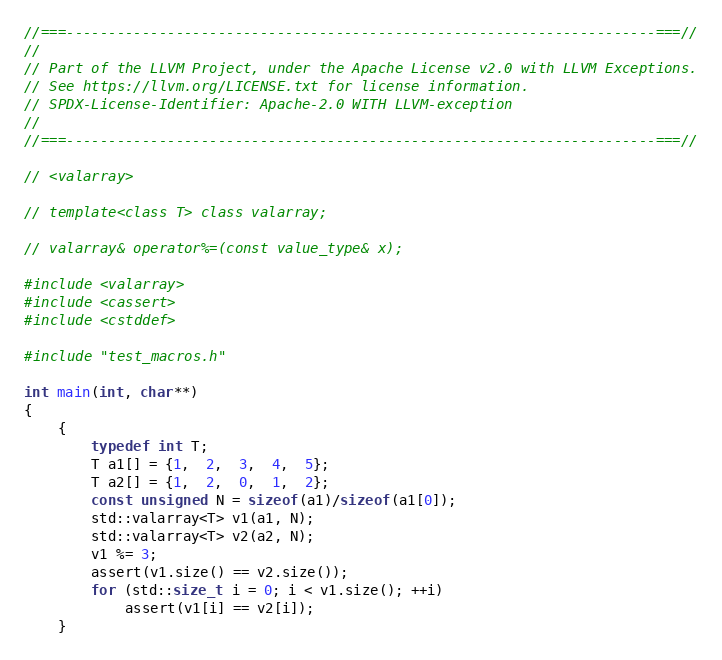<code> <loc_0><loc_0><loc_500><loc_500><_C++_>//===----------------------------------------------------------------------===//
//
// Part of the LLVM Project, under the Apache License v2.0 with LLVM Exceptions.
// See https://llvm.org/LICENSE.txt for license information.
// SPDX-License-Identifier: Apache-2.0 WITH LLVM-exception
//
//===----------------------------------------------------------------------===//

// <valarray>

// template<class T> class valarray;

// valarray& operator%=(const value_type& x);

#include <valarray>
#include <cassert>
#include <cstddef>

#include "test_macros.h"

int main(int, char**)
{
    {
        typedef int T;
        T a1[] = {1,  2,  3,  4,  5};
        T a2[] = {1,  2,  0,  1,  2};
        const unsigned N = sizeof(a1)/sizeof(a1[0]);
        std::valarray<T> v1(a1, N);
        std::valarray<T> v2(a2, N);
        v1 %= 3;
        assert(v1.size() == v2.size());
        for (std::size_t i = 0; i < v1.size(); ++i)
            assert(v1[i] == v2[i]);
    }
</code> 